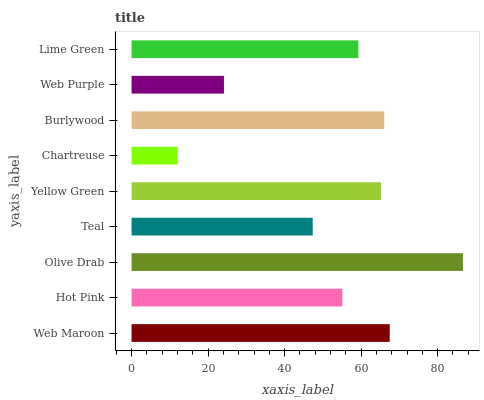Is Chartreuse the minimum?
Answer yes or no. Yes. Is Olive Drab the maximum?
Answer yes or no. Yes. Is Hot Pink the minimum?
Answer yes or no. No. Is Hot Pink the maximum?
Answer yes or no. No. Is Web Maroon greater than Hot Pink?
Answer yes or no. Yes. Is Hot Pink less than Web Maroon?
Answer yes or no. Yes. Is Hot Pink greater than Web Maroon?
Answer yes or no. No. Is Web Maroon less than Hot Pink?
Answer yes or no. No. Is Lime Green the high median?
Answer yes or no. Yes. Is Lime Green the low median?
Answer yes or no. Yes. Is Web Purple the high median?
Answer yes or no. No. Is Burlywood the low median?
Answer yes or no. No. 